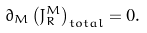<formula> <loc_0><loc_0><loc_500><loc_500>\partial _ { M } \left ( J _ { R } ^ { M } \right ) _ { t o t a l } = 0 .</formula> 